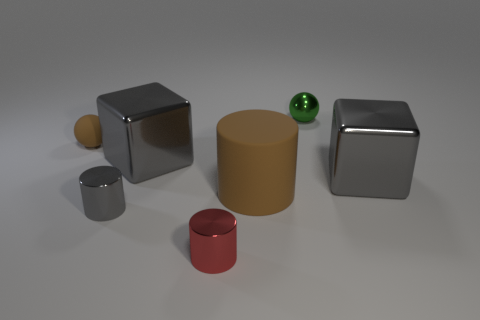Add 1 cyan metal blocks. How many objects exist? 8 Subtract all cylinders. How many objects are left? 4 Subtract 0 yellow cylinders. How many objects are left? 7 Subtract all metal cylinders. Subtract all red objects. How many objects are left? 4 Add 7 green shiny objects. How many green shiny objects are left? 8 Add 2 small green balls. How many small green balls exist? 3 